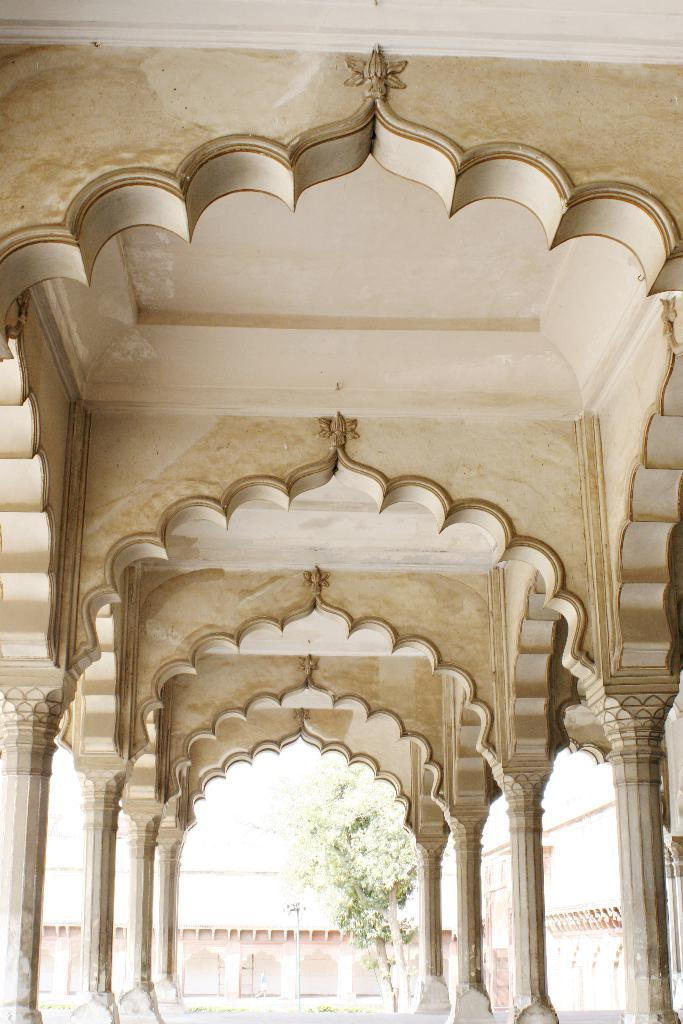What type of location is depicted in the image? The image shows an inside view of a building. What architectural features can be seen in the image? There are pillars visible in the image. What part of the building is visible in the image? The ceiling is visible in the image. What can be seen in the background of the image? There is a building and a tree in the background of the image. What type of glass is used to make the cream visible in the image? There is no glass or cream present in the image. 